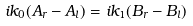<formula> <loc_0><loc_0><loc_500><loc_500>i k _ { 0 } ( A _ { r } - A _ { l } ) = i k _ { 1 } ( B _ { r } - B _ { l } )</formula> 